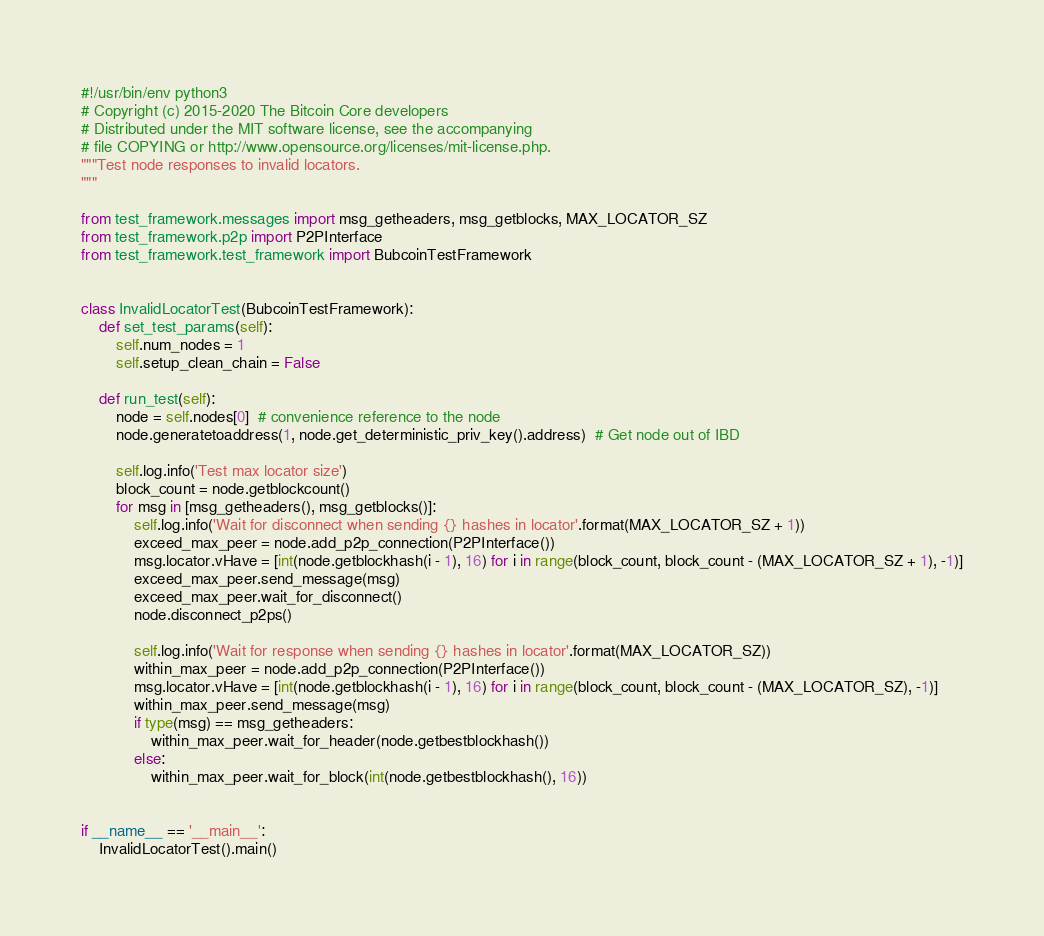Convert code to text. <code><loc_0><loc_0><loc_500><loc_500><_Python_>#!/usr/bin/env python3
# Copyright (c) 2015-2020 The Bitcoin Core developers
# Distributed under the MIT software license, see the accompanying
# file COPYING or http://www.opensource.org/licenses/mit-license.php.
"""Test node responses to invalid locators.
"""

from test_framework.messages import msg_getheaders, msg_getblocks, MAX_LOCATOR_SZ
from test_framework.p2p import P2PInterface
from test_framework.test_framework import BubcoinTestFramework


class InvalidLocatorTest(BubcoinTestFramework):
    def set_test_params(self):
        self.num_nodes = 1
        self.setup_clean_chain = False

    def run_test(self):
        node = self.nodes[0]  # convenience reference to the node
        node.generatetoaddress(1, node.get_deterministic_priv_key().address)  # Get node out of IBD

        self.log.info('Test max locator size')
        block_count = node.getblockcount()
        for msg in [msg_getheaders(), msg_getblocks()]:
            self.log.info('Wait for disconnect when sending {} hashes in locator'.format(MAX_LOCATOR_SZ + 1))
            exceed_max_peer = node.add_p2p_connection(P2PInterface())
            msg.locator.vHave = [int(node.getblockhash(i - 1), 16) for i in range(block_count, block_count - (MAX_LOCATOR_SZ + 1), -1)]
            exceed_max_peer.send_message(msg)
            exceed_max_peer.wait_for_disconnect()
            node.disconnect_p2ps()

            self.log.info('Wait for response when sending {} hashes in locator'.format(MAX_LOCATOR_SZ))
            within_max_peer = node.add_p2p_connection(P2PInterface())
            msg.locator.vHave = [int(node.getblockhash(i - 1), 16) for i in range(block_count, block_count - (MAX_LOCATOR_SZ), -1)]
            within_max_peer.send_message(msg)
            if type(msg) == msg_getheaders:
                within_max_peer.wait_for_header(node.getbestblockhash())
            else:
                within_max_peer.wait_for_block(int(node.getbestblockhash(), 16))


if __name__ == '__main__':
    InvalidLocatorTest().main()
</code> 